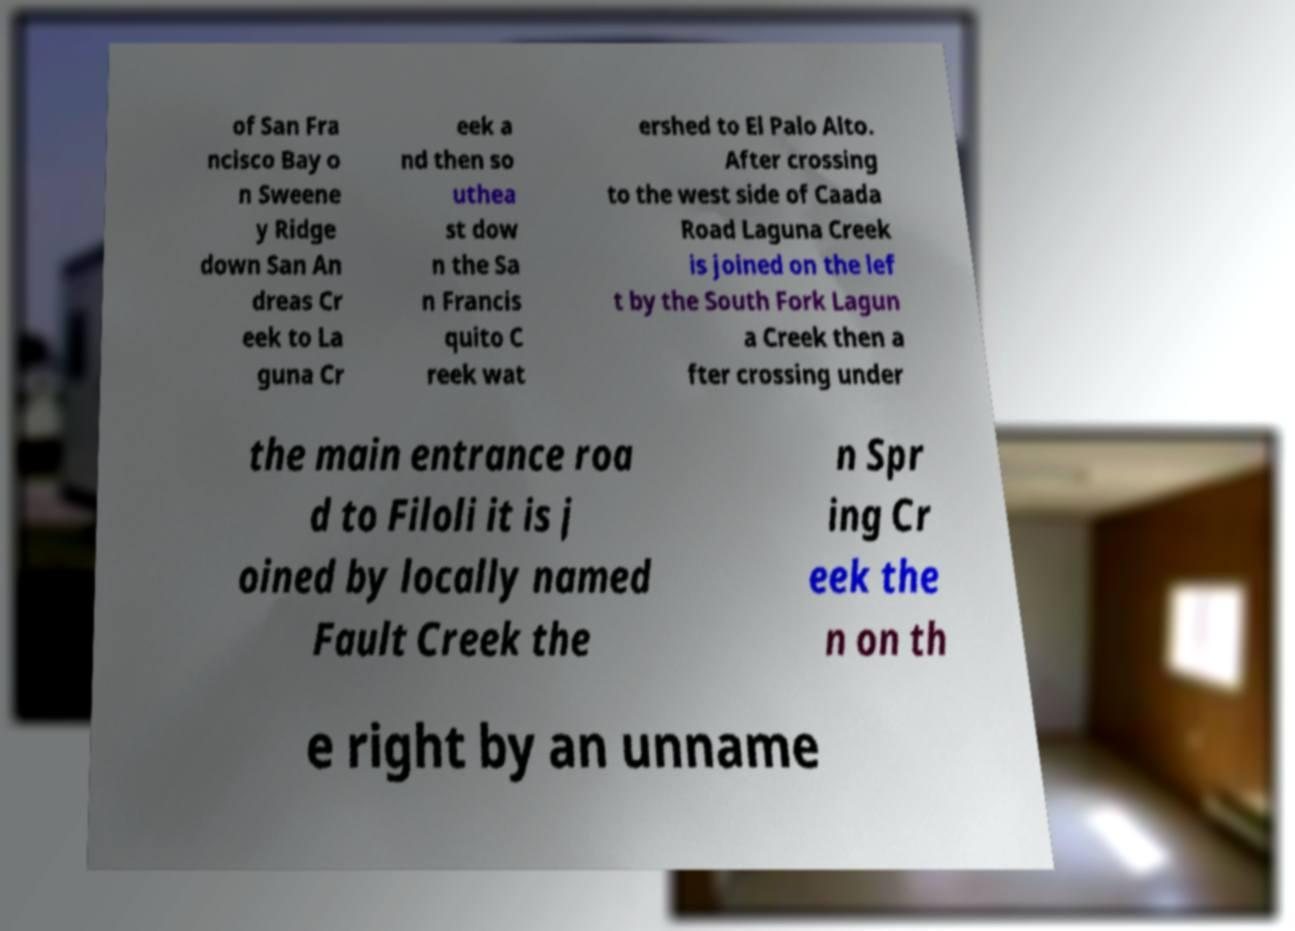I need the written content from this picture converted into text. Can you do that? of San Fra ncisco Bay o n Sweene y Ridge down San An dreas Cr eek to La guna Cr eek a nd then so uthea st dow n the Sa n Francis quito C reek wat ershed to El Palo Alto. After crossing to the west side of Caada Road Laguna Creek is joined on the lef t by the South Fork Lagun a Creek then a fter crossing under the main entrance roa d to Filoli it is j oined by locally named Fault Creek the n Spr ing Cr eek the n on th e right by an unname 